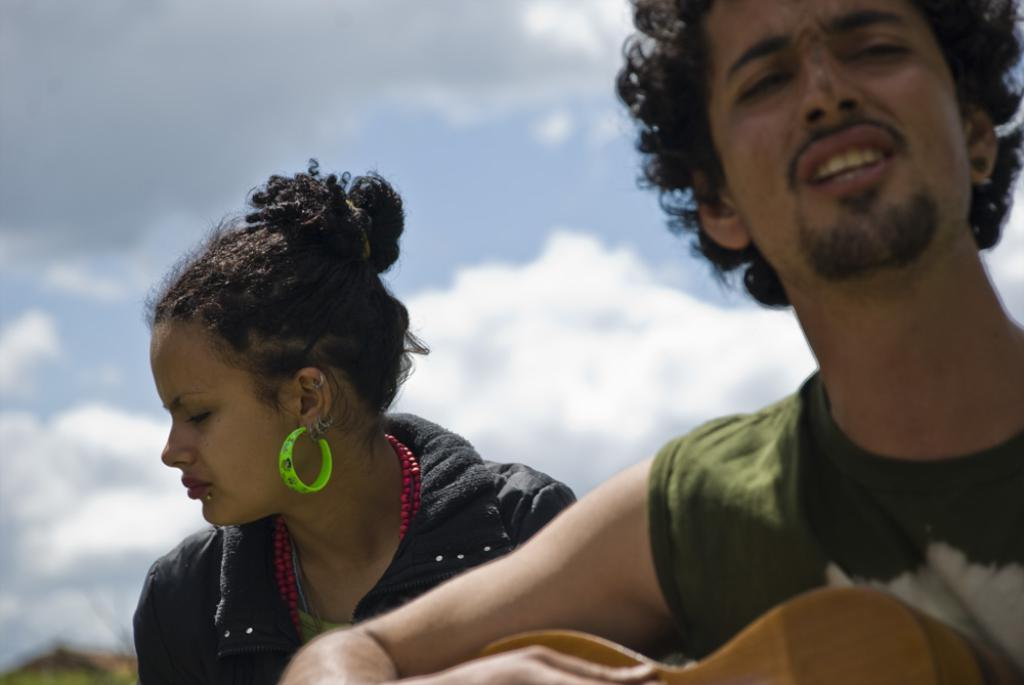Where was the image taken? The image is taken outdoors. What can be seen in the sky in the image? There is a sky with clouds visible in the image. Can you describe the people in the image? There is a man on the right side of the image and a woman in the middle of the image. What type of gate can be seen in the bedroom in the image? There is no gate or bedroom present in the image; it is taken outdoors with a sky and people. 